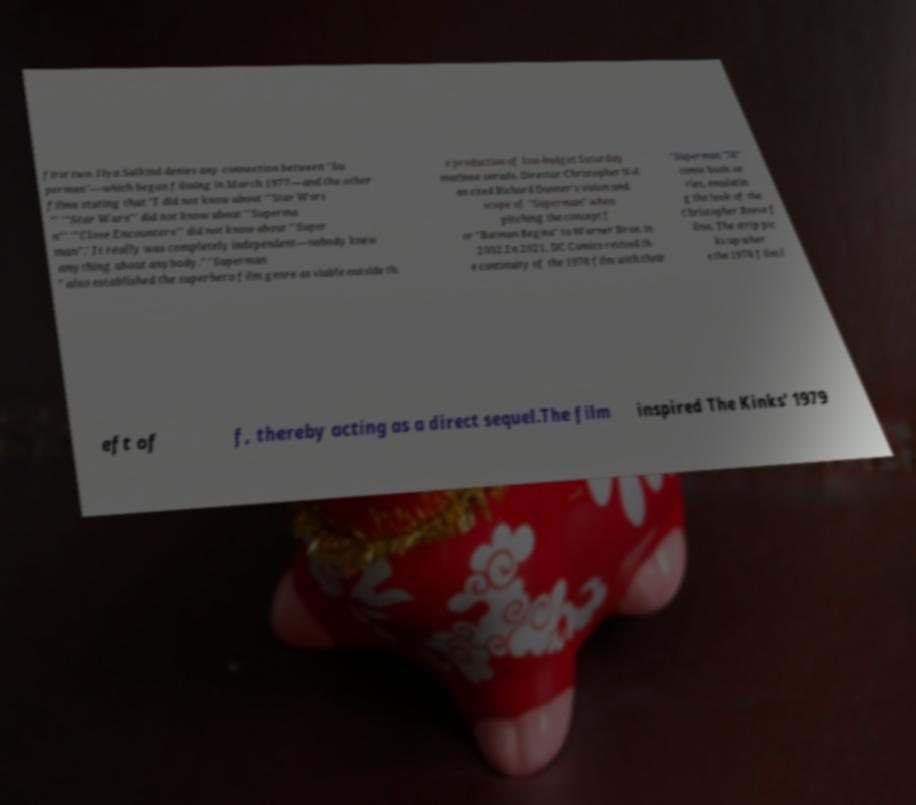There's text embedded in this image that I need extracted. Can you transcribe it verbatim? first two. Ilya Salkind denies any connection between "Su perman"—which began filming in March 1977—and the other films stating that "I did not know about '"Star Wars "' '"Star Wars"' did not know about '"Superma n"' '"Close Encounters"' did not know about "'Super man".' It really was completely independent—nobody knew anything about anybody." "Superman " also established the superhero film genre as viable outside th e production of low-budget Saturday matinee serials. Director Christopher Nol an cited Richard Donner's vision and scope of "Superman" when pitching the concept f or "Batman Begins" to Warner Bros. in 2002.In 2021, DC Comics revived th e continuity of the 1978 film with their "Superman '78" comic book se ries, emulatin g the look of the Christopher Reeve f ilms. The strip pic ks up wher e the 1978 film l eft of f, thereby acting as a direct sequel.The film inspired The Kinks' 1979 